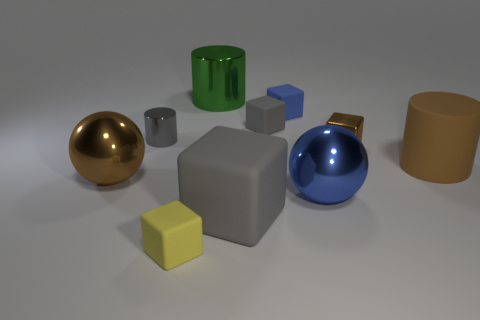Subtract all brown blocks. How many blocks are left? 4 Subtract all small yellow rubber blocks. How many blocks are left? 4 Subtract all red blocks. Subtract all blue balls. How many blocks are left? 5 Subtract all balls. How many objects are left? 8 Subtract 0 cyan cylinders. How many objects are left? 10 Subtract all brown metal objects. Subtract all matte cubes. How many objects are left? 4 Add 6 brown shiny balls. How many brown shiny balls are left? 7 Add 10 tiny purple objects. How many tiny purple objects exist? 10 